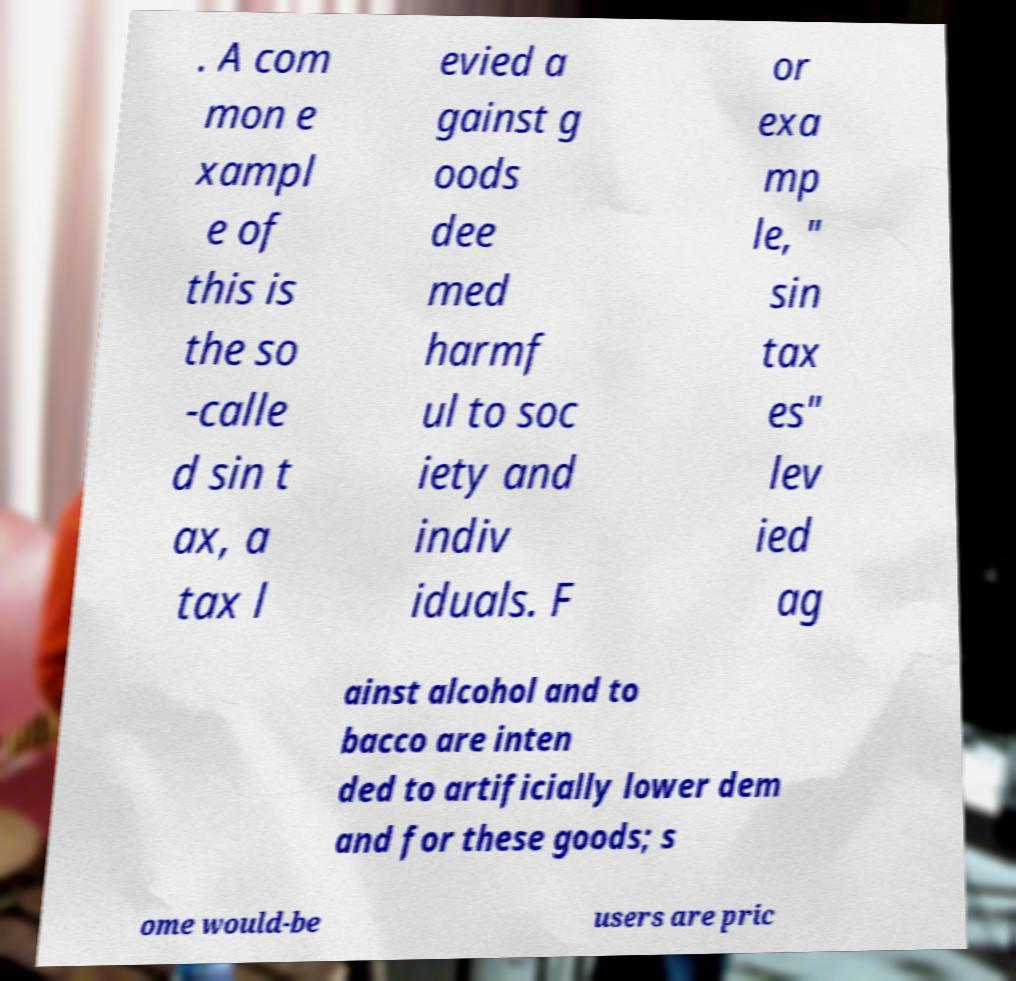Can you read and provide the text displayed in the image?This photo seems to have some interesting text. Can you extract and type it out for me? . A com mon e xampl e of this is the so -calle d sin t ax, a tax l evied a gainst g oods dee med harmf ul to soc iety and indiv iduals. F or exa mp le, " sin tax es" lev ied ag ainst alcohol and to bacco are inten ded to artificially lower dem and for these goods; s ome would-be users are pric 